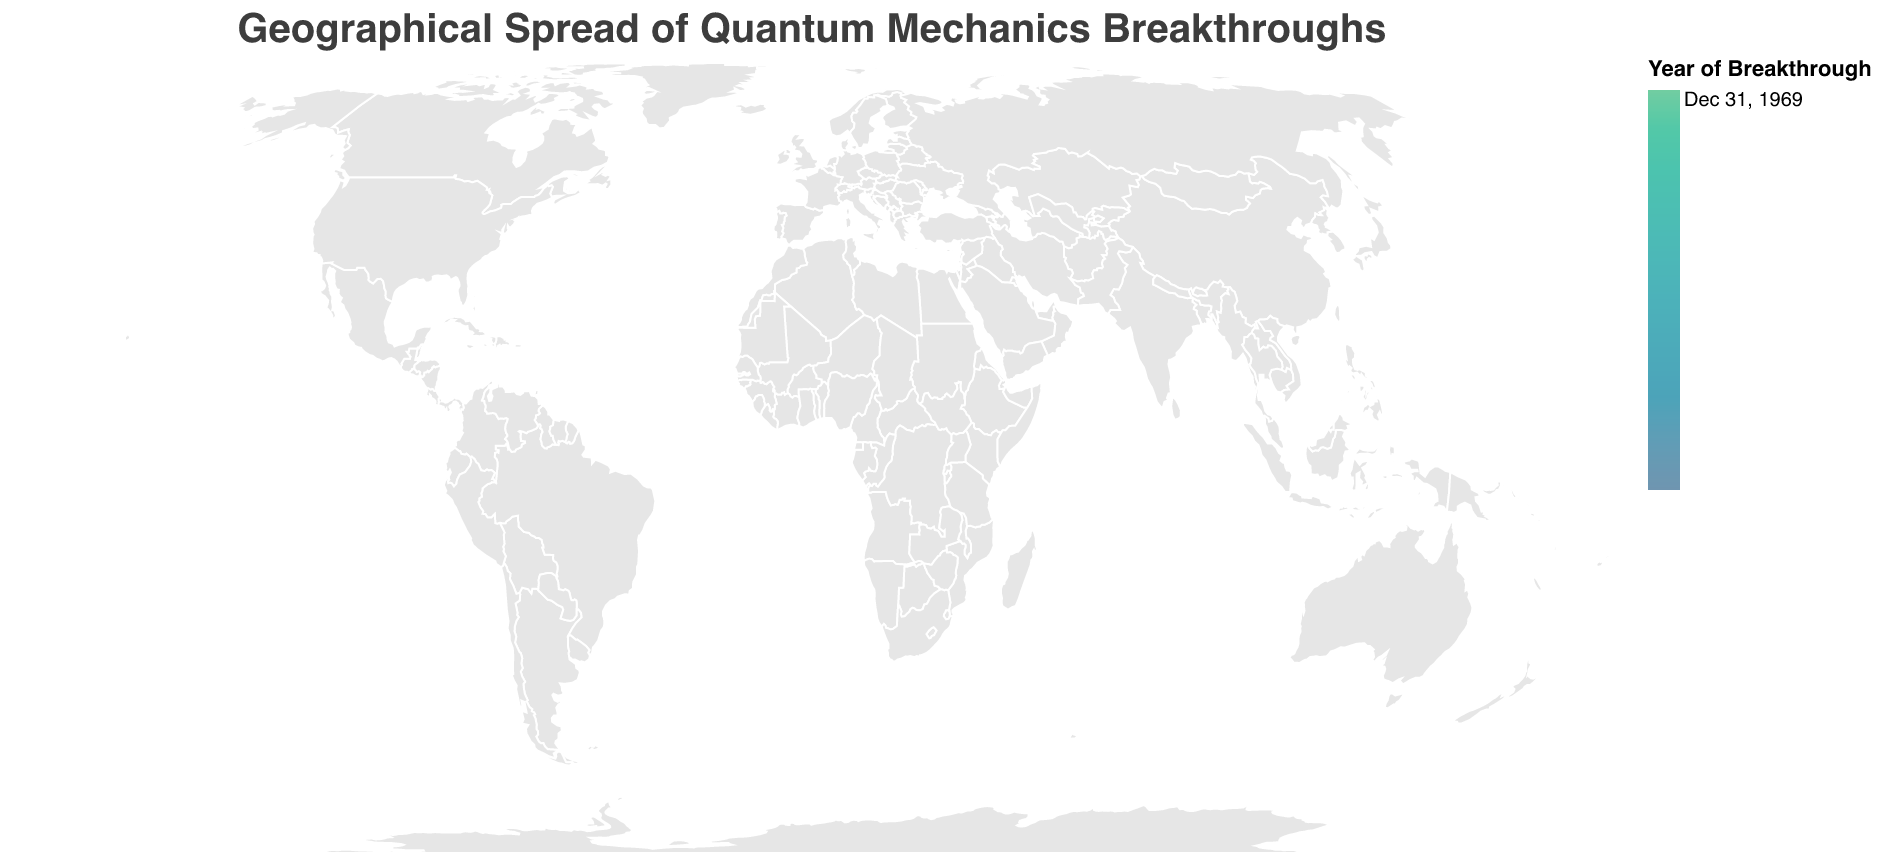What is the title of the plot? The title of the plot is usually displayed prominently at the top. Here, it is "Geographical Spread of Quantum Mechanics Breakthroughs".
Answer: Geographical Spread of Quantum Mechanics Breakthroughs How many scientific breakthroughs are represented on the map? By counting the data points (circles) on the map, we can determine the number of scientific breakthroughs shown. There are ten distinct data points listed in the data and mapped to the geographical plot.
Answer: 10 Which institution had the breakthrough with the highest impact score? The impact scores are visually represented by the size of the circles. The largest circle should correspond to the highest impact score. By examining the tooltip or the list, "University of Cambridge" with the Dirac Equation in 1928 has an impact score of 10.0.
Answer: University of Cambridge What is the most recent breakthrough on the map and which institution made it? The color legend indicates the years, with more recent years generally represented by a different color shade. By referring to the tooltip or list, the most recent breakthrough is "Quantum Hall Effect" at École Normale Supérieure in 1980.
Answer: École Normale Supérieure, 1980 How does the impact score of the BCS Theory of Superconductivity compare to Quantum Entanglement? To compare, we look at the impact scores: BCS Theory at MIT (9.8) and Quantum Entanglement at Friedrich Schiller University Jena (9.6). BCS Theory of Superconductivity has a higher impact score than Quantum Entanglement.
Answer: BCS Theory of Superconductivity is higher Which region or continent has the most breakthroughs represented on the map? By visually assessing the concentration of data points, we can determine which region is most represented. Europe appears to have the highest concentration, with several institutions like University of Warsaw, École Normale Supérieure, University of Cambridge, and Friedrich Schiller University Jena.
Answer: Europe What is the average impact score of all the breakthroughs shown on the map? Sum up all the impact scores and divide by the number of breakthroughs: (8.5 + 7.2 + 9.8 + 8.9 + 9.5 + 9.1 + 10.0 + 9.3 + 8.7 + 9.6)/10 = 9.06
Answer: 9.1 Which breakthrough occurred earliest, and what is its institution? Referring to the tooltip or list, sorting by the year, the earliest breakthrough is "Dirac Equation" at the University of Cambridge in 1928.
Answer: Dirac Equation, University of Cambridge, 1928 How many breakthroughs have an impact score greater than 9.0? By checking the impact scores in the data: BCS Theory of Superconductivity (9.8), Quantum Hall Effect (9.5), Nambu-Goldstone Theorem (9.1), Dirac Equation (10.0), Lamb Shift (9.3), and Quantum Entanglement (9.6). There are six breakthroughs with an impact score greater than 9.0.
Answer: 6 